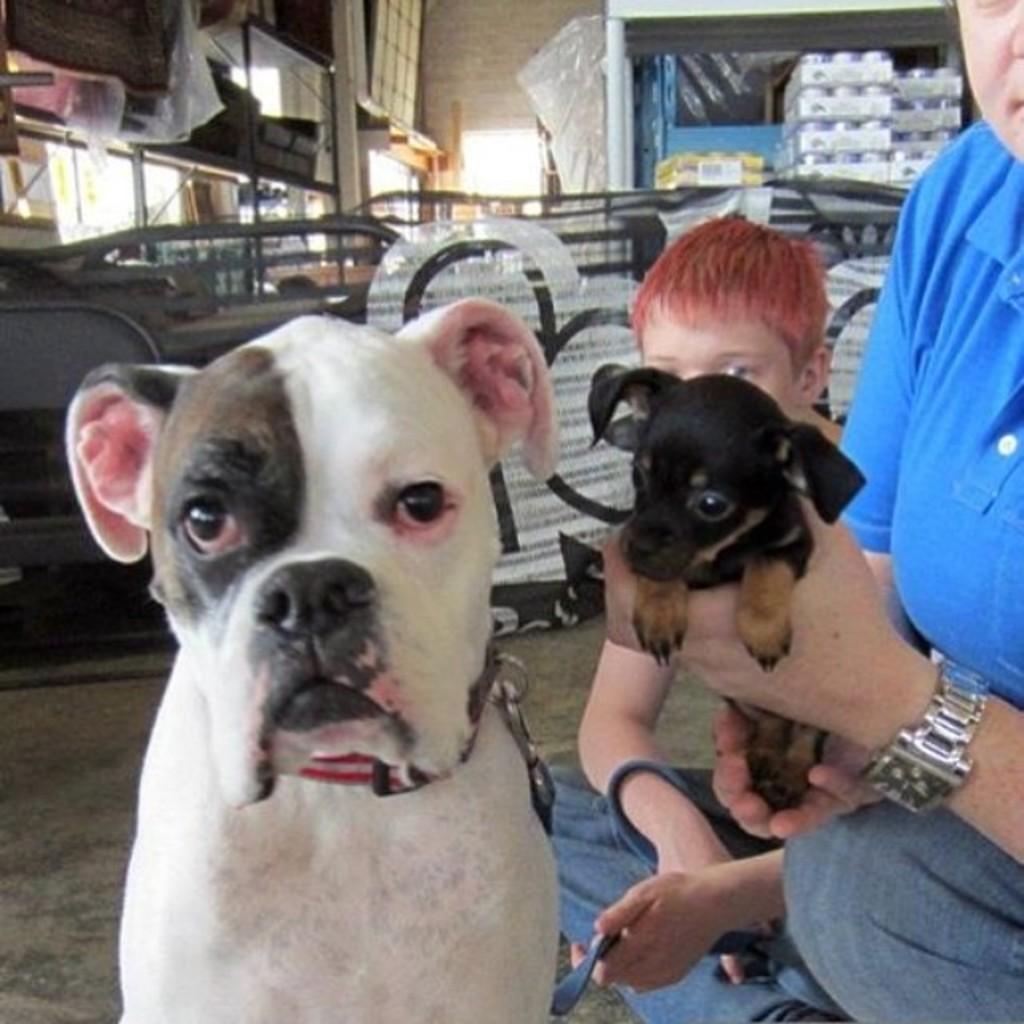Please provide a concise description of this image. there is a dog and at the right there are 2 persons. the person at the right most corner is holding a small puppy. 